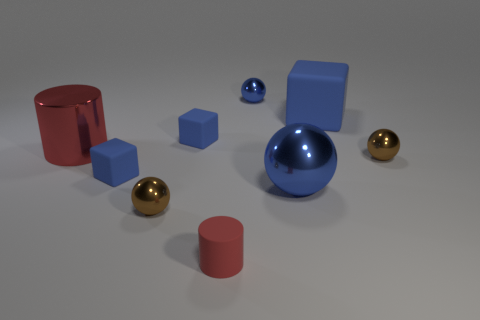Are there any patterns or symmetry in the arrangement of objects? There isn't a strict pattern or symmetry, but there is a loose radial arrangement with the large blue sphere near the center acting as a focal point. Objects are scattered outward from this center in a somewhat balanced distribution, providing a harmonious visual effect. 